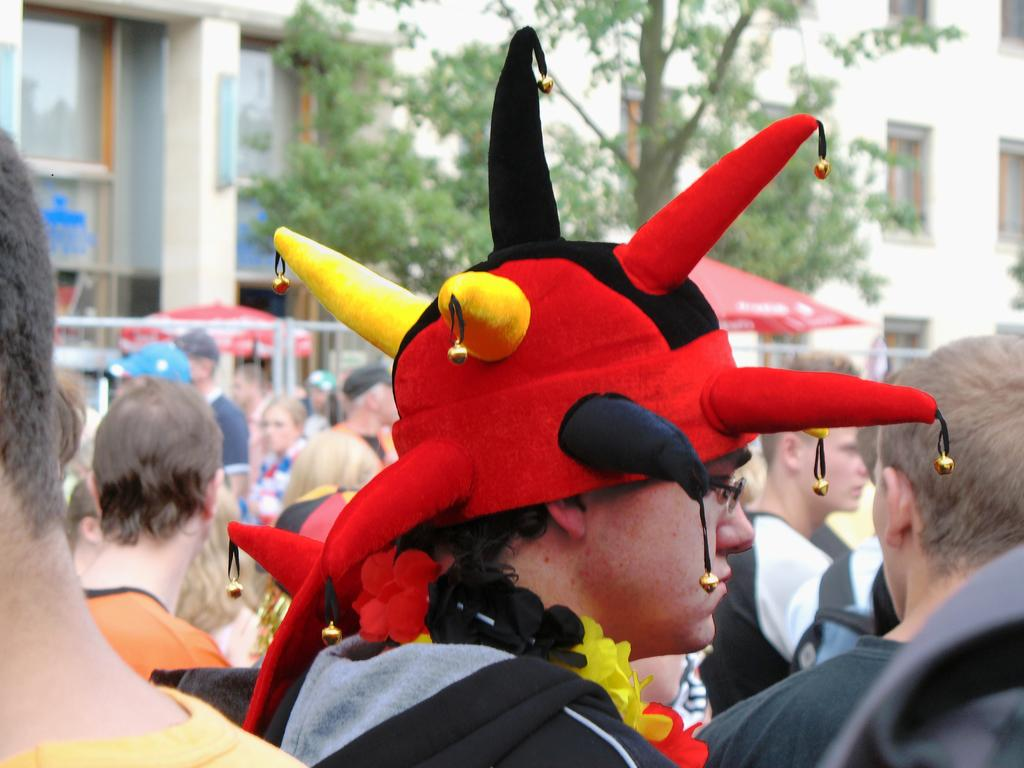What is the person in the image wearing on their head? The person in the image is wearing a colorful hat and garland. How many people are in the image? There is a group of people in the image. What can be seen in the background of the image? There are buildings, pillars, trees, and walls in the background of the image. Is there any object providing shade in the background? Yes, there is an umbrella in the background of the image. What type of soap is being used by the person in the image? There is no soap present in the image; the person is wearing a hat and garland. What role does the spoon play in the image? There is no spoon present in the image. 